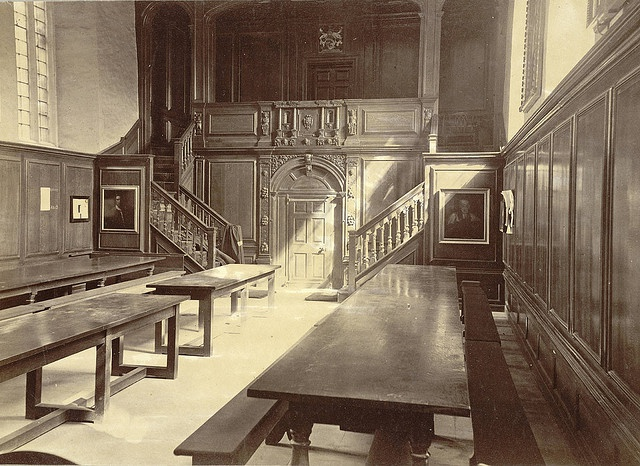Describe the objects in this image and their specific colors. I can see dining table in lightgray, gray, and black tones, dining table in lightgray, gray, maroon, and tan tones, bench in lightgray, maroon, black, and gray tones, bench in lightgray, gray, and maroon tones, and dining table in lightgray, beige, gray, tan, and black tones in this image. 